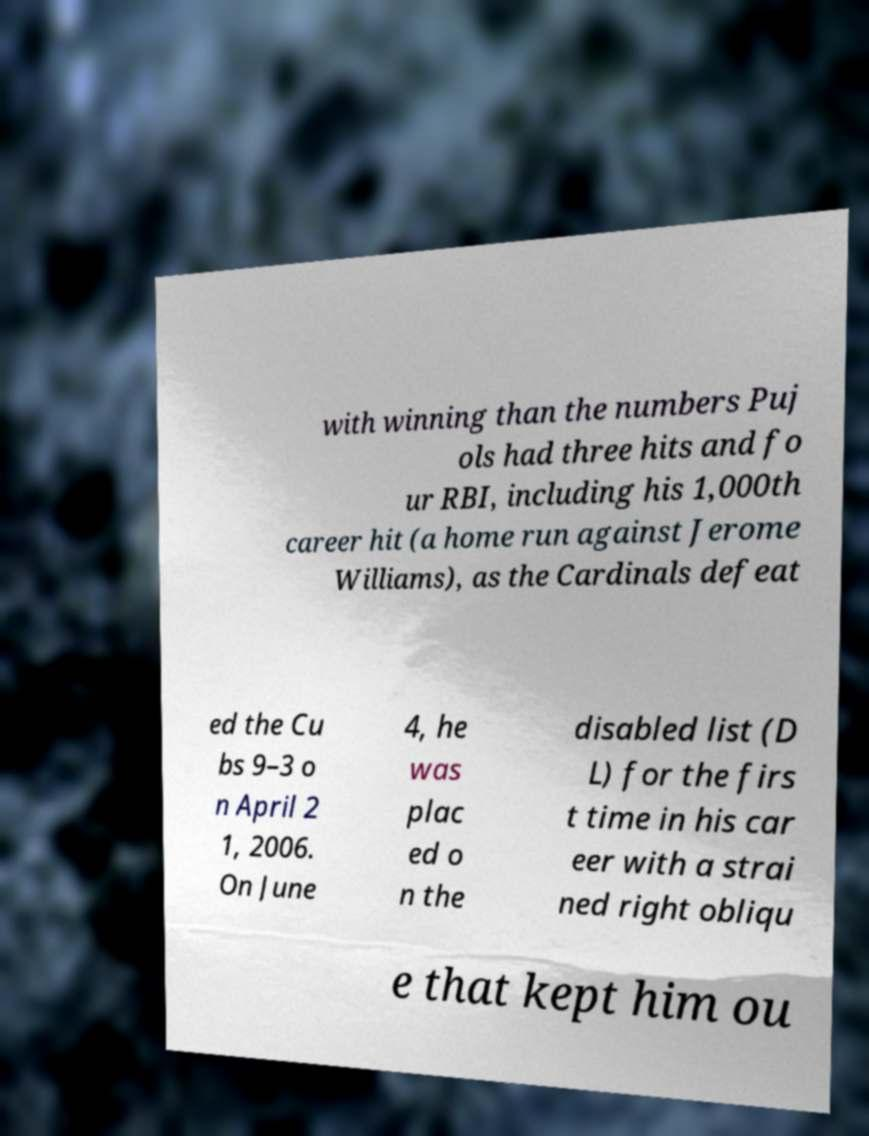I need the written content from this picture converted into text. Can you do that? with winning than the numbers Puj ols had three hits and fo ur RBI, including his 1,000th career hit (a home run against Jerome Williams), as the Cardinals defeat ed the Cu bs 9–3 o n April 2 1, 2006. On June 4, he was plac ed o n the disabled list (D L) for the firs t time in his car eer with a strai ned right obliqu e that kept him ou 